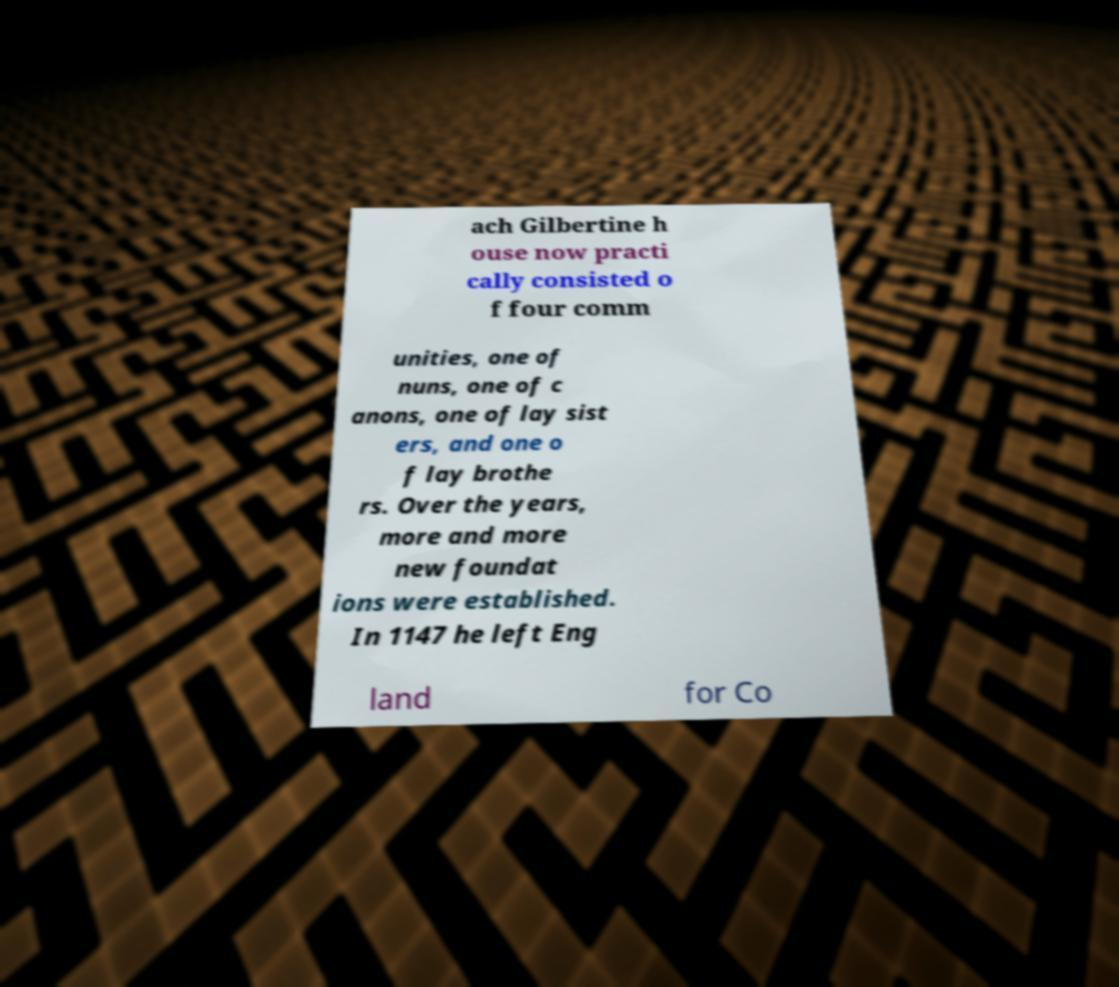Can you read and provide the text displayed in the image?This photo seems to have some interesting text. Can you extract and type it out for me? ach Gilbertine h ouse now practi cally consisted o f four comm unities, one of nuns, one of c anons, one of lay sist ers, and one o f lay brothe rs. Over the years, more and more new foundat ions were established. In 1147 he left Eng land for Co 